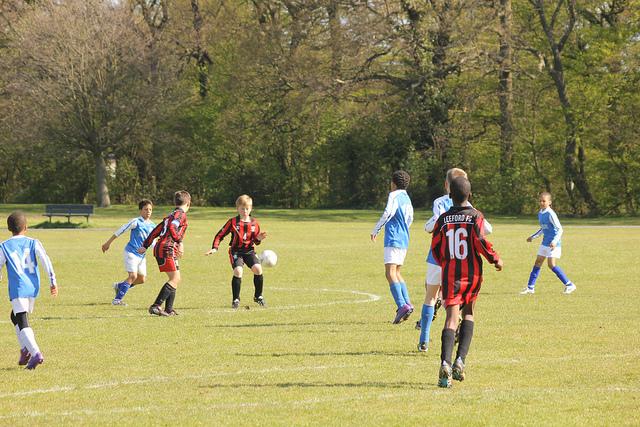How many people are pictured?
Give a very brief answer. 8. What sport is being played?
Answer briefly. Soccer. How many people are playing?
Be succinct. 8. Is the ball in the air?
Write a very short answer. Yes. Are these kids all on the same team?
Quick response, please. No. How many children wear blue and white uniforms?
Keep it brief. 5. 